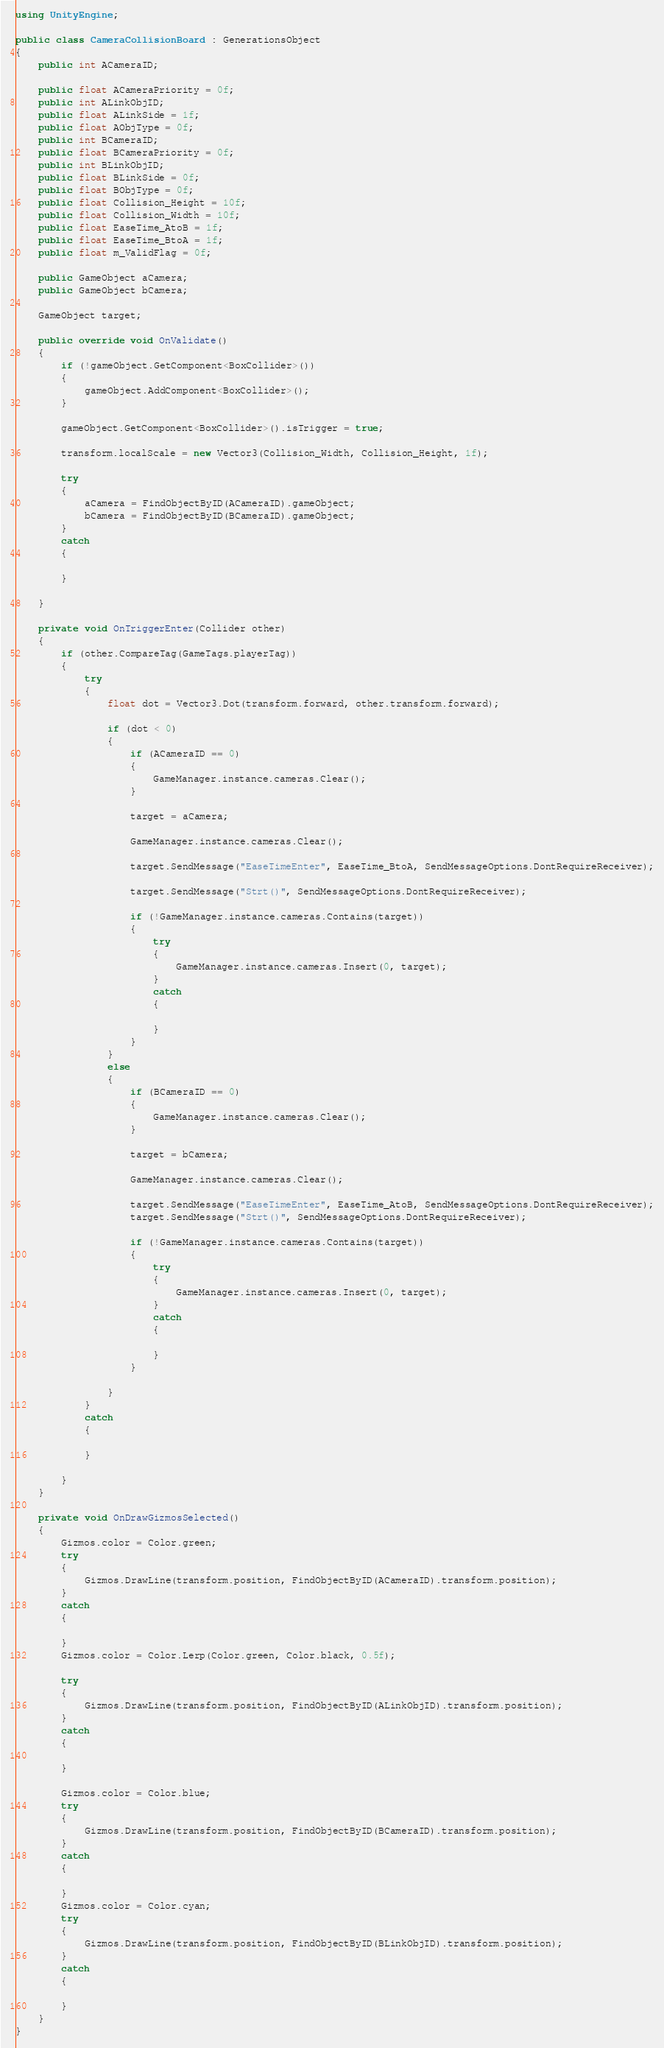Convert code to text. <code><loc_0><loc_0><loc_500><loc_500><_C#_>using UnityEngine;

public class CameraCollisionBoard : GenerationsObject
{
    public int ACameraID;

    public float ACameraPriority = 0f;
    public int ALinkObjID;
    public float ALinkSide = 1f;
    public float AObjType = 0f;
    public int BCameraID;
    public float BCameraPriority = 0f;
    public int BLinkObjID;
    public float BLinkSide = 0f;
    public float BObjType = 0f;
    public float Collision_Height = 10f;
    public float Collision_Width = 10f;
    public float EaseTime_AtoB = 1f;
    public float EaseTime_BtoA = 1f;
    public float m_ValidFlag = 0f;

    public GameObject aCamera;
    public GameObject bCamera;

    GameObject target;

    public override void OnValidate()
    {
        if (!gameObject.GetComponent<BoxCollider>())
        {
            gameObject.AddComponent<BoxCollider>();
        }

        gameObject.GetComponent<BoxCollider>().isTrigger = true;

        transform.localScale = new Vector3(Collision_Width, Collision_Height, 1f);

        try
        {
            aCamera = FindObjectByID(ACameraID).gameObject;
            bCamera = FindObjectByID(BCameraID).gameObject;
        }
        catch
        {

        }

    }

    private void OnTriggerEnter(Collider other)
    {
        if (other.CompareTag(GameTags.playerTag))
        {
            try
            {
                float dot = Vector3.Dot(transform.forward, other.transform.forward);

                if (dot < 0)
                {
                    if (ACameraID == 0)
                    {
                        GameManager.instance.cameras.Clear();
                    }

                    target = aCamera;

                    GameManager.instance.cameras.Clear();

                    target.SendMessage("EaseTimeEnter", EaseTime_BtoA, SendMessageOptions.DontRequireReceiver);

                    target.SendMessage("Strt()", SendMessageOptions.DontRequireReceiver);

                    if (!GameManager.instance.cameras.Contains(target))
                    {
                        try
                        {
                            GameManager.instance.cameras.Insert(0, target);
                        }
                        catch
                        {

                        }
                    }
                }
                else
                {
                    if (BCameraID == 0)
                    {
                        GameManager.instance.cameras.Clear();
                    }

                    target = bCamera;

                    GameManager.instance.cameras.Clear();

                    target.SendMessage("EaseTimeEnter", EaseTime_AtoB, SendMessageOptions.DontRequireReceiver);
                    target.SendMessage("Strt()", SendMessageOptions.DontRequireReceiver);

                    if (!GameManager.instance.cameras.Contains(target))
                    {
                        try
                        {
                            GameManager.instance.cameras.Insert(0, target);
                        }
                        catch
                        {

                        }
                    }

                }
            }
            catch
            {

            }

        }
    }

    private void OnDrawGizmosSelected()
    {
        Gizmos.color = Color.green;
        try
        {
            Gizmos.DrawLine(transform.position, FindObjectByID(ACameraID).transform.position);
        }
        catch
        {

        }
        Gizmos.color = Color.Lerp(Color.green, Color.black, 0.5f);

        try
        {
            Gizmos.DrawLine(transform.position, FindObjectByID(ALinkObjID).transform.position);
        }
        catch
        {

        }

        Gizmos.color = Color.blue;
        try
        {
            Gizmos.DrawLine(transform.position, FindObjectByID(BCameraID).transform.position);
        }
        catch
        {

        }
        Gizmos.color = Color.cyan;
        try
        {
            Gizmos.DrawLine(transform.position, FindObjectByID(BLinkObjID).transform.position);
        }
        catch
        {

        }
    }
}</code> 